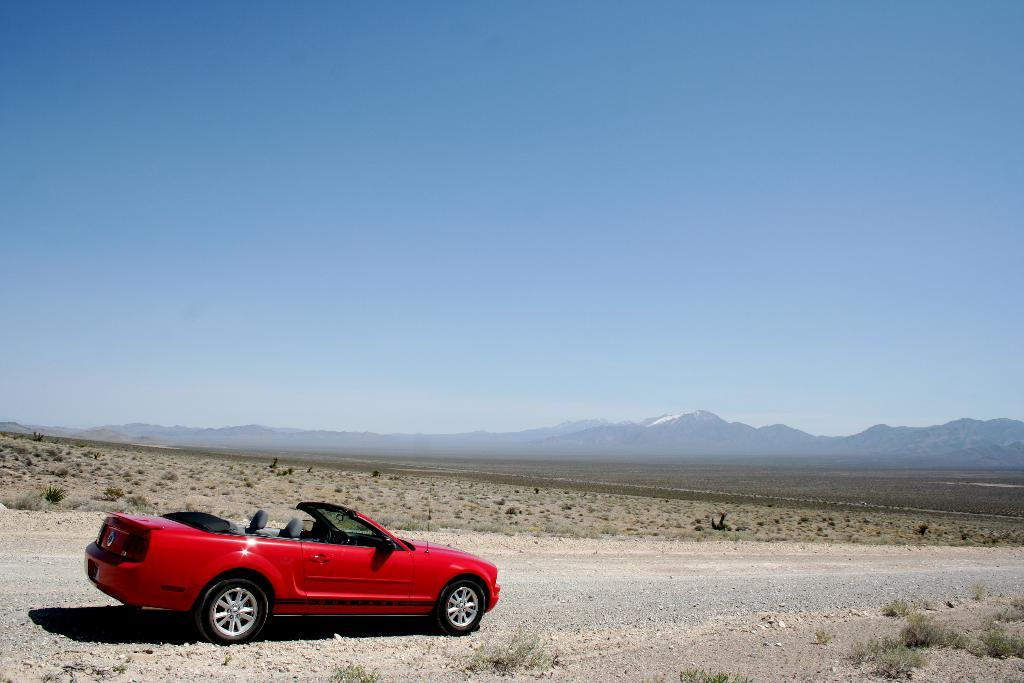What is the main subject of the image? The main subject of the image is a car on the road. Where is the car located in the image? The car is at the bottom of the image. What can be seen in the background of the image? There are mountains in the background of the image. What is visible at the top of the image? The sky is visible at the top of the image. Are there any fairies flying around the car in the image? There are no fairies present in the image. What reward does the car receive for driving on the road in the image? The car does not receive any reward for driving on the road in the image; it is simply depicted in the scene. 